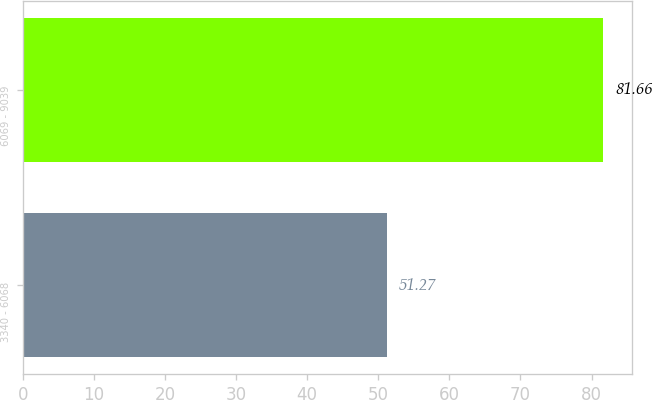<chart> <loc_0><loc_0><loc_500><loc_500><bar_chart><fcel>3340 - 6068<fcel>6069 - 9039<nl><fcel>51.27<fcel>81.66<nl></chart> 